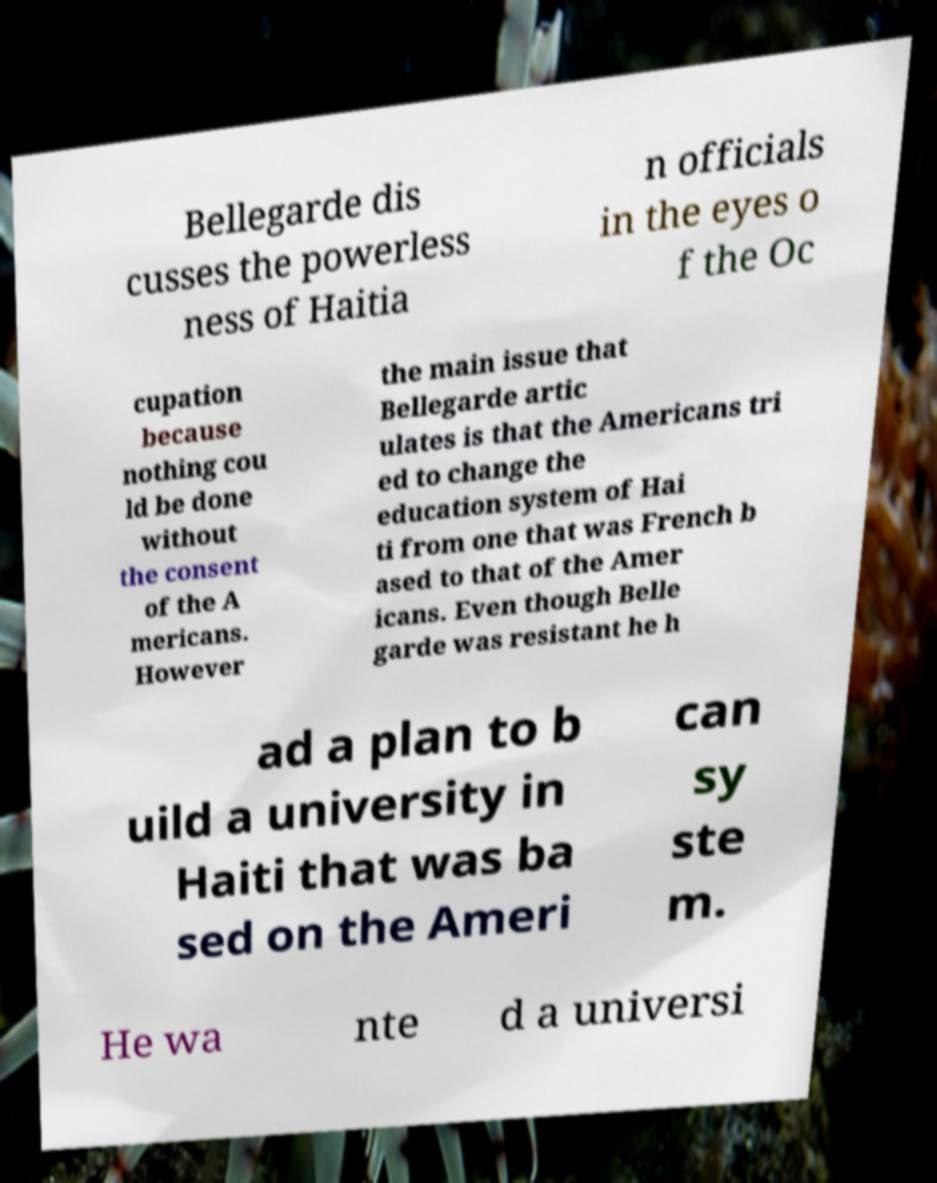There's text embedded in this image that I need extracted. Can you transcribe it verbatim? Bellegarde dis cusses the powerless ness of Haitia n officials in the eyes o f the Oc cupation because nothing cou ld be done without the consent of the A mericans. However the main issue that Bellegarde artic ulates is that the Americans tri ed to change the education system of Hai ti from one that was French b ased to that of the Amer icans. Even though Belle garde was resistant he h ad a plan to b uild a university in Haiti that was ba sed on the Ameri can sy ste m. He wa nte d a universi 